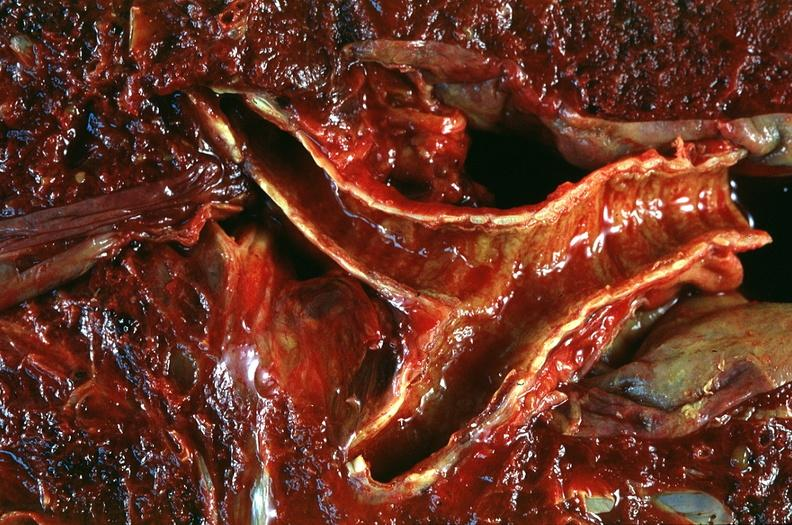does this image show lung, emphysema and bronchial hemorrhage, alpha-1 antitrypsin deficiency?
Answer the question using a single word or phrase. Yes 